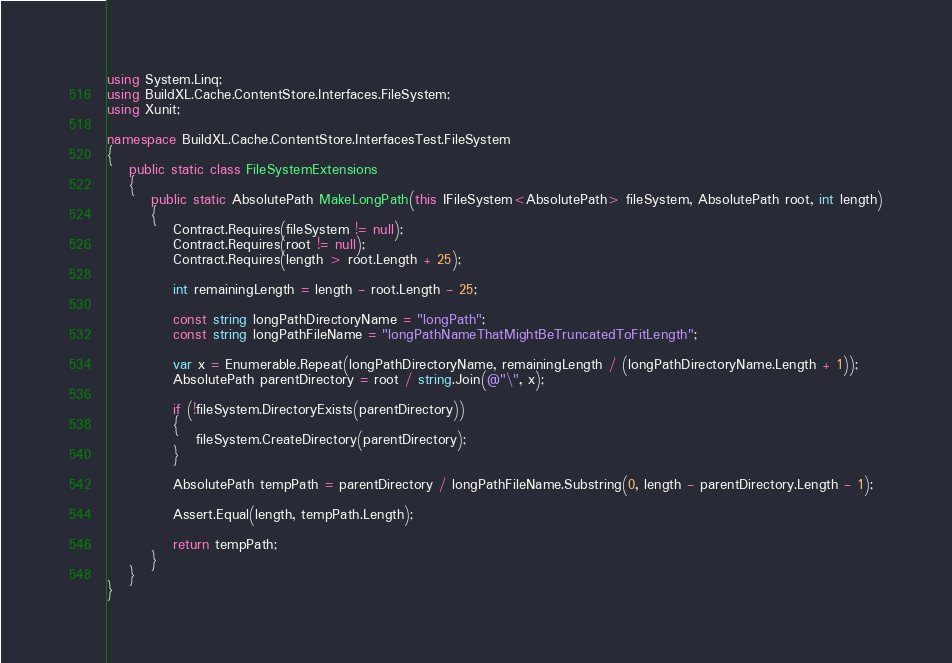<code> <loc_0><loc_0><loc_500><loc_500><_C#_>using System.Linq;
using BuildXL.Cache.ContentStore.Interfaces.FileSystem;
using Xunit;

namespace BuildXL.Cache.ContentStore.InterfacesTest.FileSystem
{
    public static class FileSystemExtensions
    {
        public static AbsolutePath MakeLongPath(this IFileSystem<AbsolutePath> fileSystem, AbsolutePath root, int length)
        {
            Contract.Requires(fileSystem != null);
            Contract.Requires(root != null);
            Contract.Requires(length > root.Length + 25);

            int remainingLength = length - root.Length - 25;

            const string longPathDirectoryName = "longPath";
            const string longPathFileName = "longPathNameThatMightBeTruncatedToFitLength";

            var x = Enumerable.Repeat(longPathDirectoryName, remainingLength / (longPathDirectoryName.Length + 1));
            AbsolutePath parentDirectory = root / string.Join(@"\", x);

            if (!fileSystem.DirectoryExists(parentDirectory))
            {
                fileSystem.CreateDirectory(parentDirectory);
            }

            AbsolutePath tempPath = parentDirectory / longPathFileName.Substring(0, length - parentDirectory.Length - 1);

            Assert.Equal(length, tempPath.Length);

            return tempPath;
        }
    }
}
</code> 